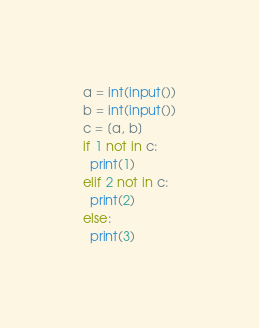Convert code to text. <code><loc_0><loc_0><loc_500><loc_500><_Python_>a = int(input())
b = int(input())
c = [a, b]
if 1 not in c:
  print(1)
elif 2 not in c:
  print(2)
else:
  print(3)
</code> 